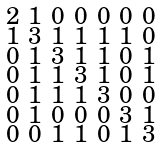<formula> <loc_0><loc_0><loc_500><loc_500>\begin{smallmatrix} 2 & 1 & 0 & 0 & 0 & 0 & 0 \\ 1 & 3 & 1 & 1 & 1 & 1 & 0 \\ 0 & 1 & 3 & 1 & 1 & 0 & 1 \\ 0 & 1 & 1 & 3 & 1 & 0 & 1 \\ 0 & 1 & 1 & 1 & 3 & 0 & 0 \\ 0 & 1 & 0 & 0 & 0 & 3 & 1 \\ 0 & 0 & 1 & 1 & 0 & 1 & 3 \end{smallmatrix}</formula> 